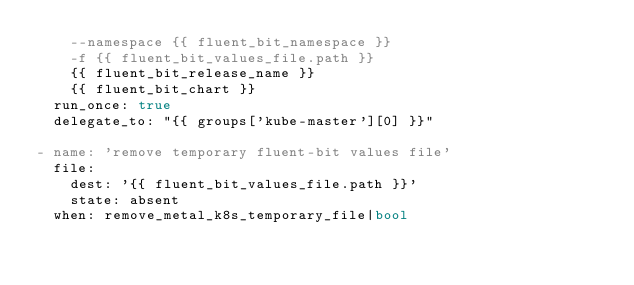<code> <loc_0><loc_0><loc_500><loc_500><_YAML_>    --namespace {{ fluent_bit_namespace }}
    -f {{ fluent_bit_values_file.path }}
    {{ fluent_bit_release_name }}
    {{ fluent_bit_chart }}
  run_once: true
  delegate_to: "{{ groups['kube-master'][0] }}"

- name: 'remove temporary fluent-bit values file'
  file:
    dest: '{{ fluent_bit_values_file.path }}'
    state: absent
  when: remove_metal_k8s_temporary_file|bool
</code> 